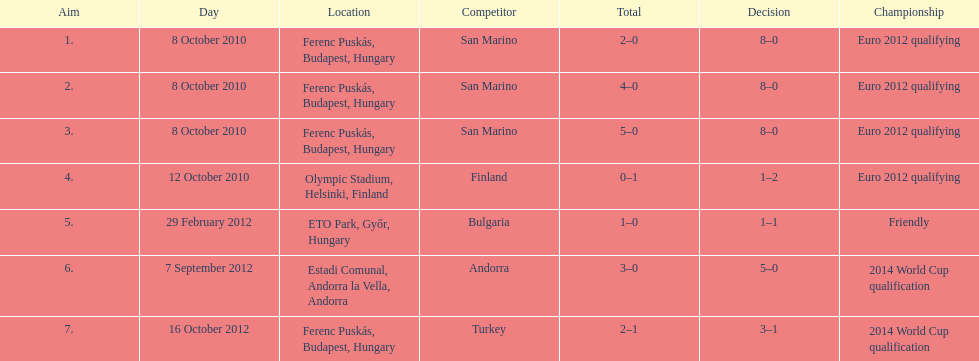In which year did szalai score his initial international goal? 2010. 